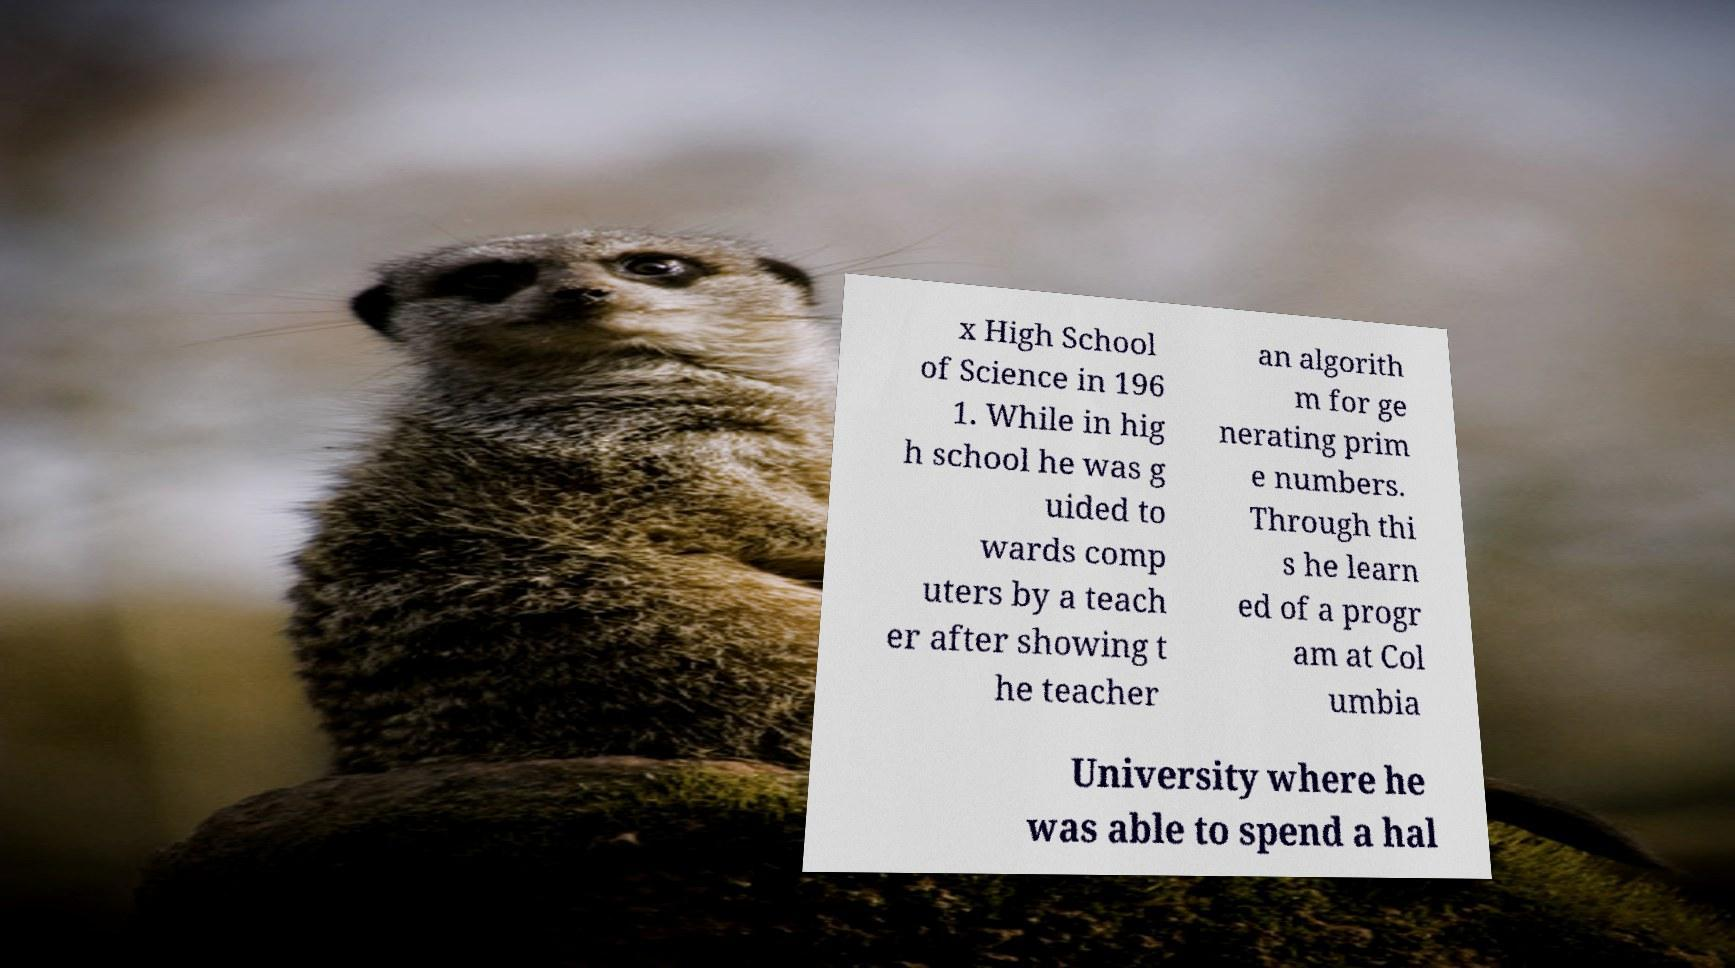Please read and relay the text visible in this image. What does it say? x High School of Science in 196 1. While in hig h school he was g uided to wards comp uters by a teach er after showing t he teacher an algorith m for ge nerating prim e numbers. Through thi s he learn ed of a progr am at Col umbia University where he was able to spend a hal 